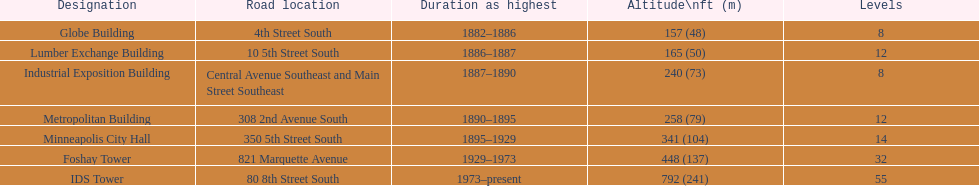How long did the lumber exchange building stand as the tallest building? 1 year. Write the full table. {'header': ['Designation', 'Road location', 'Duration as highest', 'Altitude\\nft (m)', 'Levels'], 'rows': [['Globe Building', '4th Street South', '1882–1886', '157 (48)', '8'], ['Lumber Exchange Building', '10 5th Street South', '1886–1887', '165 (50)', '12'], ['Industrial Exposition Building', 'Central Avenue Southeast and Main Street Southeast', '1887–1890', '240 (73)', '8'], ['Metropolitan Building', '308 2nd Avenue South', '1890–1895', '258 (79)', '12'], ['Minneapolis City Hall', '350 5th Street South', '1895–1929', '341 (104)', '14'], ['Foshay Tower', '821 Marquette Avenue', '1929–1973', '448 (137)', '32'], ['IDS Tower', '80 8th Street South', '1973–present', '792 (241)', '55']]} 